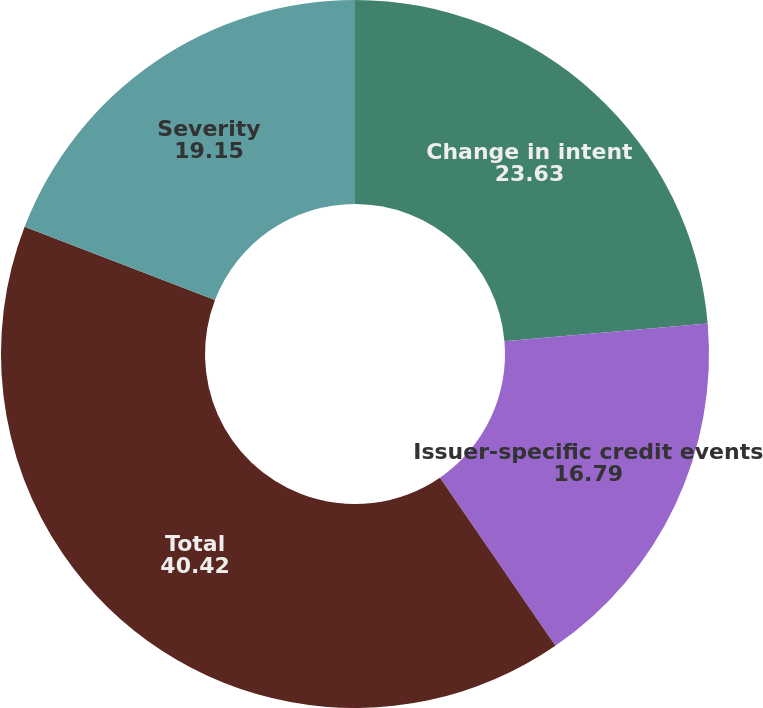Convert chart to OTSL. <chart><loc_0><loc_0><loc_500><loc_500><pie_chart><fcel>Change in intent<fcel>Issuer-specific credit events<fcel>Total<fcel>Severity<nl><fcel>23.63%<fcel>16.79%<fcel>40.42%<fcel>19.15%<nl></chart> 